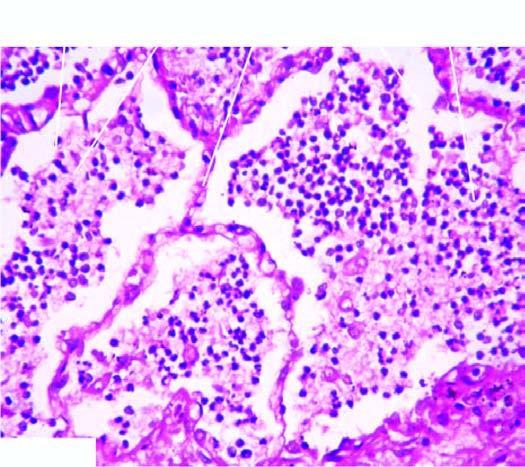what is lying separated from the septal walls by a clear space?
Answer the question using a single word or phrase. Cellular exudates in the alveolar lumina 